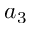Convert formula to latex. <formula><loc_0><loc_0><loc_500><loc_500>a _ { 3 }</formula> 